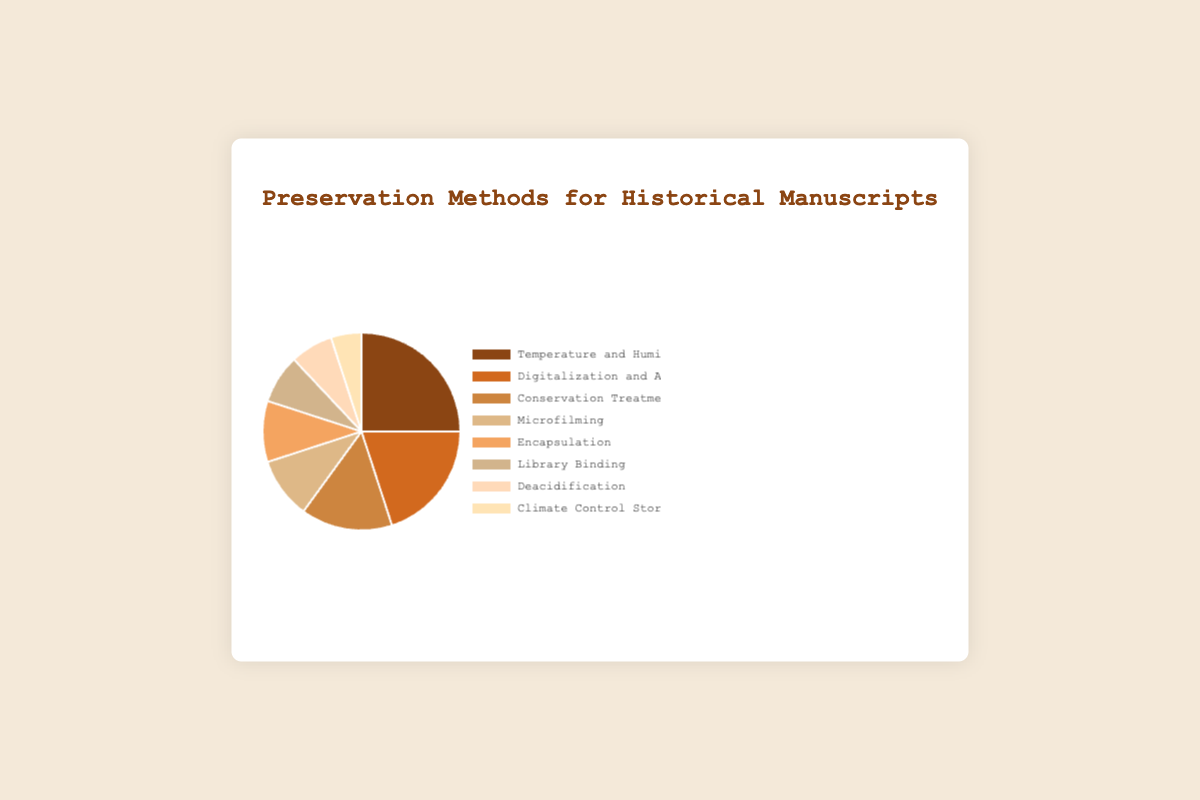What percentage of preservation methods involves controlling environmental factors (temperature, humidity, and climate control)? To find the percentage of methods that involve controlling environmental factors, sum the percentages of "Temperature and Humidity Control" (25%) and "Climate Control Storage" (5%). Therefore, 25% + 5% = 30%.
Answer: 30% Which preservation method is used more frequently between "Microfilming" and "Encapsulation"? Comparing the percentages of "Microfilming" (10%) and "Encapsulation" (10%), both methods are used equally frequently.
Answer: Both are used equally What is the difference in percentage between the most and least utilized preservation methods? The most utilized method is "Temperature and Humidity Control" with 25%, and the least utilized method is "Climate Control Storage" with 5%. The difference is 25% - 5% = 20%.
Answer: 20% How do the combined percentages of "Digitalization and Archival Imaging" and "Conservation Treatments" compare to "Temperature and Humidity Control"? Sum the percentages for "Digitalization and Archival Imaging" (20%) and "Conservation Treatments" (15%) to get 35%. Comparing this to "Temperature and Humidity Control" (25%), 35% is greater than 25%.
Answer: 35% > 25% What preservation method is represented by the darkest color in the pie chart? The preservation method with the darkest color is "Temperature and Humidity Control", which has the highest percentage (25%).
Answer: Temperature and Humidity Control What’s the total percentage for the three least utilized preservation methods? The three least utilized methods are "Climate Control Storage" (5%), "Deacidification" (7%), and "Library Binding" (8%). Summing these up: 5% + 7% + 8% = 20%.
Answer: 20% Which preservation methods combined make up half of the total preservation efforts shown in the pie chart? To find which methods make up half (50%) of the total, start summing from the largest percentages: "Temperature and Humidity Control" (25%) + "Digitalization and Archival Imaging" (20%) = 45%. Adding the next largest, "Conservation Treatments" (15%), exceeds half, so the combined methods do not exactly form 50% based on individual methods but are close with the first two methods.
Answer: Temperature and Humidity Control and Digitalization and Archival Imaging Which method is used more frequently: "Library Binding" or "Deacidification"? Comparing the percentages of "Library Binding" (8%) and "Deacidification" (7%), "Library Binding" is used more frequently.
Answer: Library Binding If a new method was introduced and took 5% of the preservation methods, what would the new percentage for "Temperature and Humidity Control" be if its percentage was reduced accordingly? Currently, "Temperature and Humidity Control" is 25%. If a new method takes 5%, reducing "Temperature and Humidity Control" by 5%, the new percentage would be 25% - 5% = 20%.
Answer: 20% What proportion of the total pie chart is made up by methods that are used less than 10% of the time each? The methods used less than 10% of the time are "Library Binding" (8%), "Deacidification" (7%), and "Climate Control Storage" (5%). Summing these: 8% + 7% + 5% = 20%.
Answer: 20% 